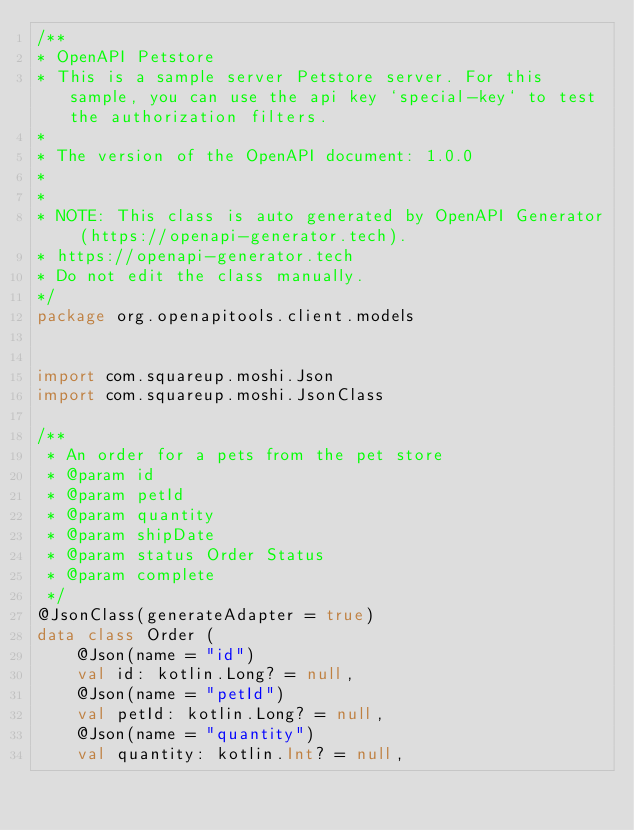<code> <loc_0><loc_0><loc_500><loc_500><_Kotlin_>/**
* OpenAPI Petstore
* This is a sample server Petstore server. For this sample, you can use the api key `special-key` to test the authorization filters.
*
* The version of the OpenAPI document: 1.0.0
* 
*
* NOTE: This class is auto generated by OpenAPI Generator (https://openapi-generator.tech).
* https://openapi-generator.tech
* Do not edit the class manually.
*/
package org.openapitools.client.models


import com.squareup.moshi.Json
import com.squareup.moshi.JsonClass

/**
 * An order for a pets from the pet store
 * @param id 
 * @param petId 
 * @param quantity 
 * @param shipDate 
 * @param status Order Status
 * @param complete 
 */
@JsonClass(generateAdapter = true)
data class Order (
    @Json(name = "id")
    val id: kotlin.Long? = null,
    @Json(name = "petId")
    val petId: kotlin.Long? = null,
    @Json(name = "quantity")
    val quantity: kotlin.Int? = null,</code> 